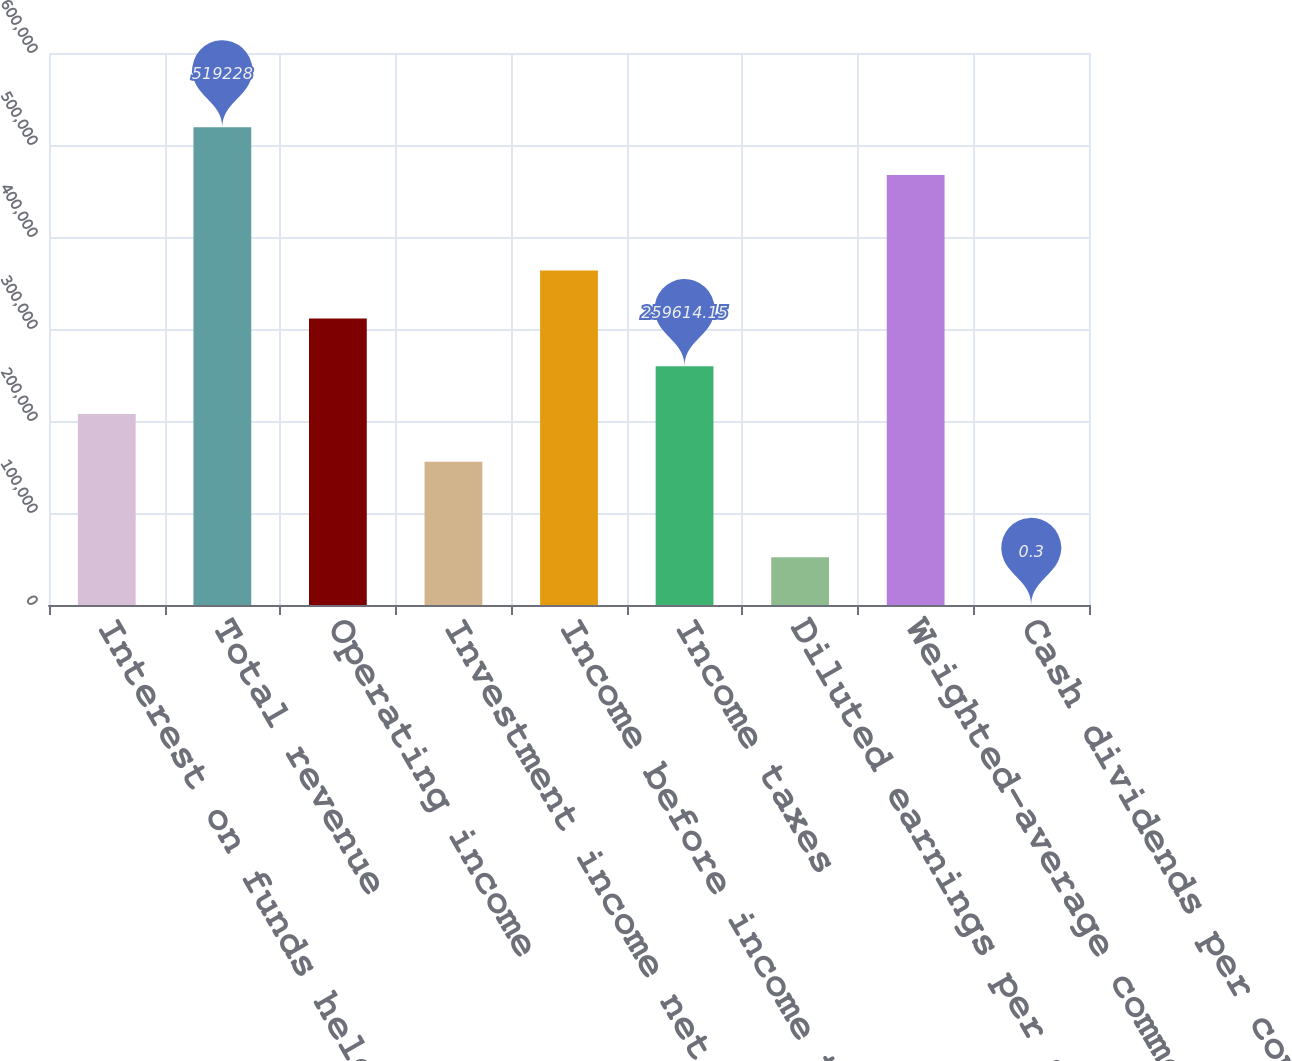Convert chart. <chart><loc_0><loc_0><loc_500><loc_500><bar_chart><fcel>Interest on funds held for<fcel>Total revenue<fcel>Operating income<fcel>Investment income net<fcel>Income before income taxes<fcel>Income taxes<fcel>Diluted earnings per share^(1)<fcel>Weighted-average common shares<fcel>Cash dividends per common<nl><fcel>207691<fcel>519228<fcel>311537<fcel>155769<fcel>363460<fcel>259614<fcel>51923.1<fcel>467305<fcel>0.3<nl></chart> 